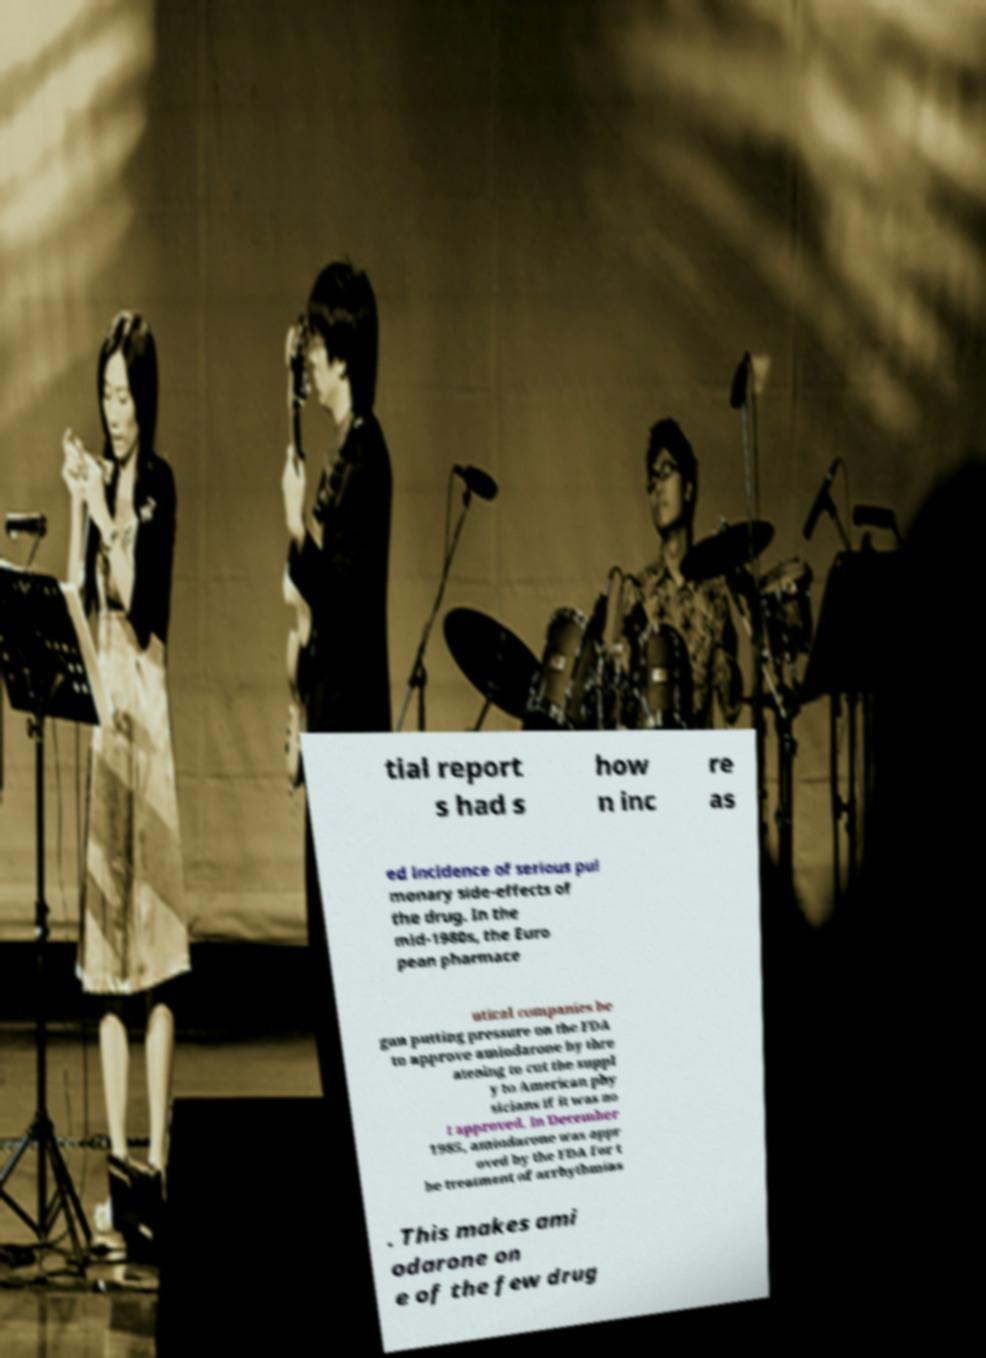There's text embedded in this image that I need extracted. Can you transcribe it verbatim? tial report s had s how n inc re as ed incidence of serious pul monary side-effects of the drug. In the mid-1980s, the Euro pean pharmace utical companies be gan putting pressure on the FDA to approve amiodarone by thre atening to cut the suppl y to American phy sicians if it was no t approved. In December 1985, amiodarone was appr oved by the FDA for t he treatment of arrhythmias . This makes ami odarone on e of the few drug 